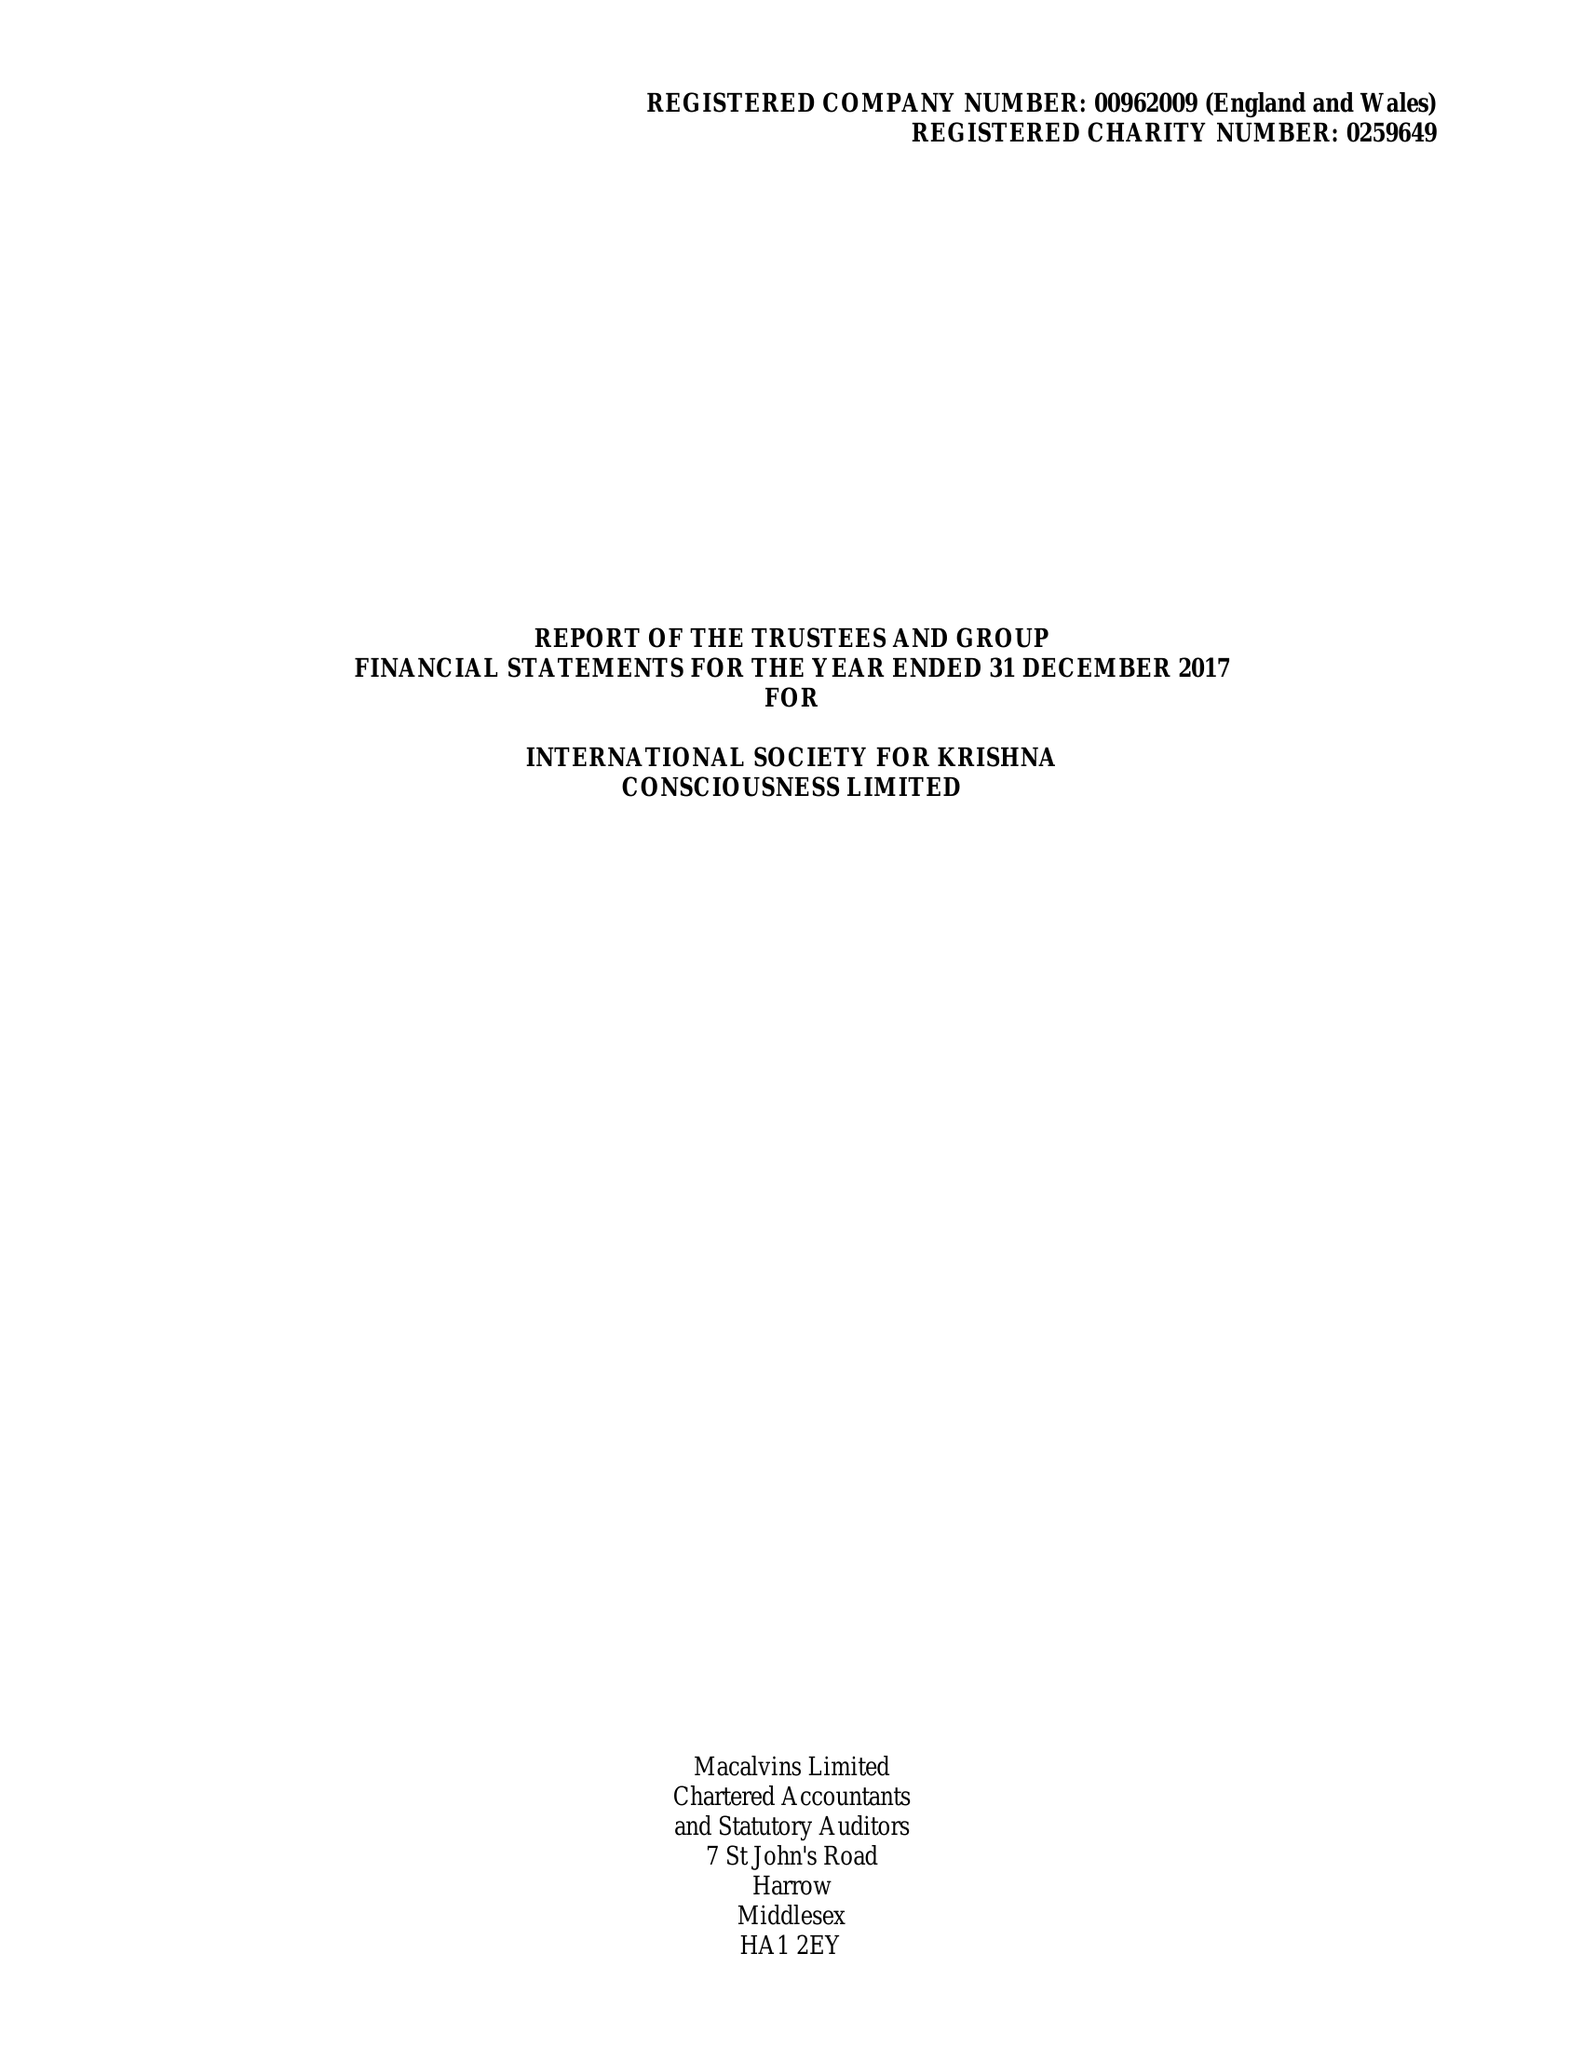What is the value for the charity_name?
Answer the question using a single word or phrase. International Society For Krishna Consciousness Ltd. 